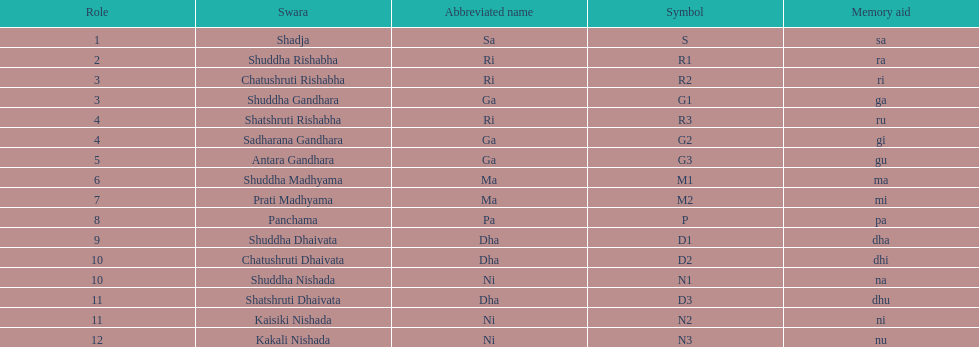Other than m1 how many notations have "1" in them? 4. Could you help me parse every detail presented in this table? {'header': ['Role', 'Swara', 'Abbreviated name', 'Symbol', 'Memory aid'], 'rows': [['1', 'Shadja', 'Sa', 'S', 'sa'], ['2', 'Shuddha Rishabha', 'Ri', 'R1', 'ra'], ['3', 'Chatushruti Rishabha', 'Ri', 'R2', 'ri'], ['3', 'Shuddha Gandhara', 'Ga', 'G1', 'ga'], ['4', 'Shatshruti Rishabha', 'Ri', 'R3', 'ru'], ['4', 'Sadharana Gandhara', 'Ga', 'G2', 'gi'], ['5', 'Antara Gandhara', 'Ga', 'G3', 'gu'], ['6', 'Shuddha Madhyama', 'Ma', 'M1', 'ma'], ['7', 'Prati Madhyama', 'Ma', 'M2', 'mi'], ['8', 'Panchama', 'Pa', 'P', 'pa'], ['9', 'Shuddha Dhaivata', 'Dha', 'D1', 'dha'], ['10', 'Chatushruti Dhaivata', 'Dha', 'D2', 'dhi'], ['10', 'Shuddha Nishada', 'Ni', 'N1', 'na'], ['11', 'Shatshruti Dhaivata', 'Dha', 'D3', 'dhu'], ['11', 'Kaisiki Nishada', 'Ni', 'N2', 'ni'], ['12', 'Kakali Nishada', 'Ni', 'N3', 'nu']]} 